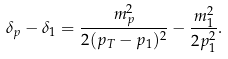Convert formula to latex. <formula><loc_0><loc_0><loc_500><loc_500>\delta _ { p } - \delta _ { 1 } = \frac { m _ { p } ^ { 2 } } { 2 ( p _ { T } - p _ { 1 } ) ^ { 2 } } - \frac { m _ { 1 } ^ { 2 } } { 2 p _ { 1 } ^ { 2 } } .</formula> 